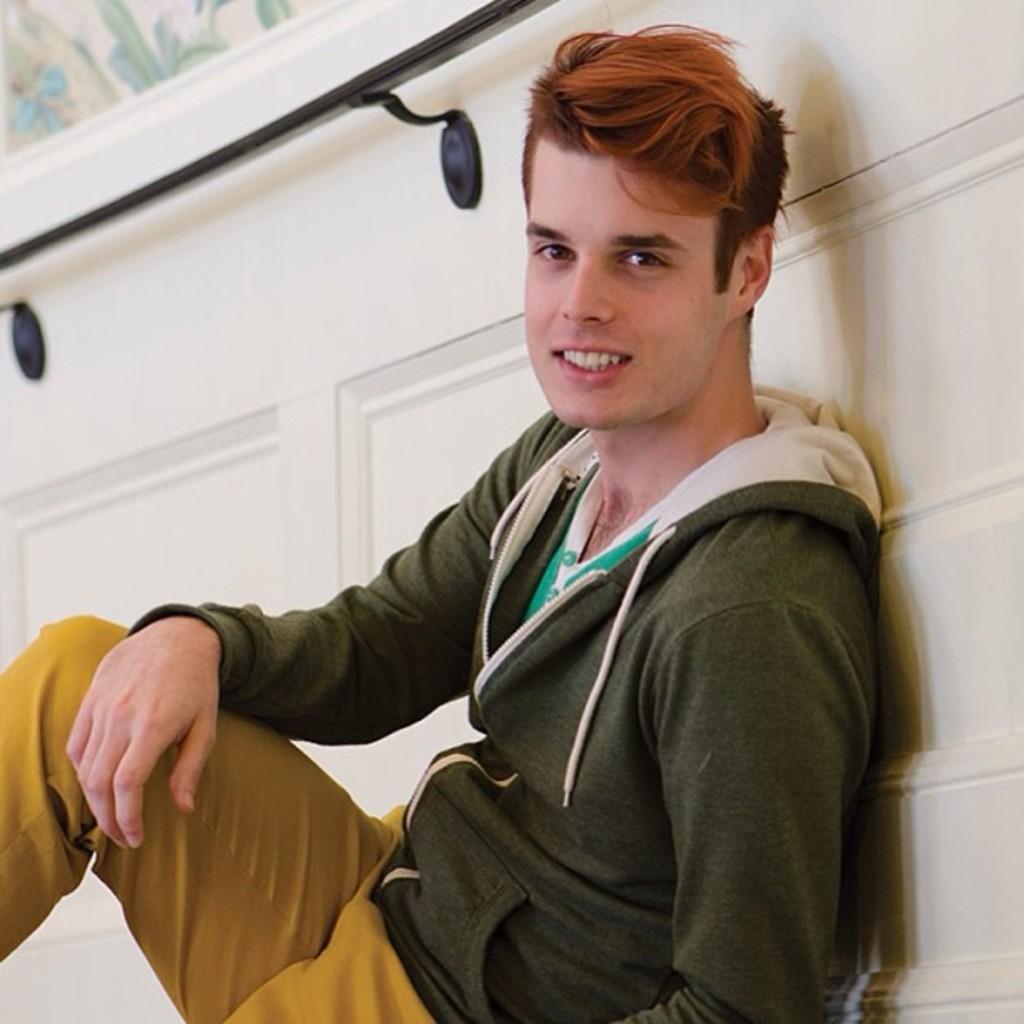Can you describe this image briefly? In the middle of the image a person is sitting and smiling. Behind him there is wall. 